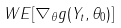<formula> <loc_0><loc_0><loc_500><loc_500>W E [ \nabla _ { \theta } g ( Y _ { t } , \theta _ { 0 } ) ]</formula> 